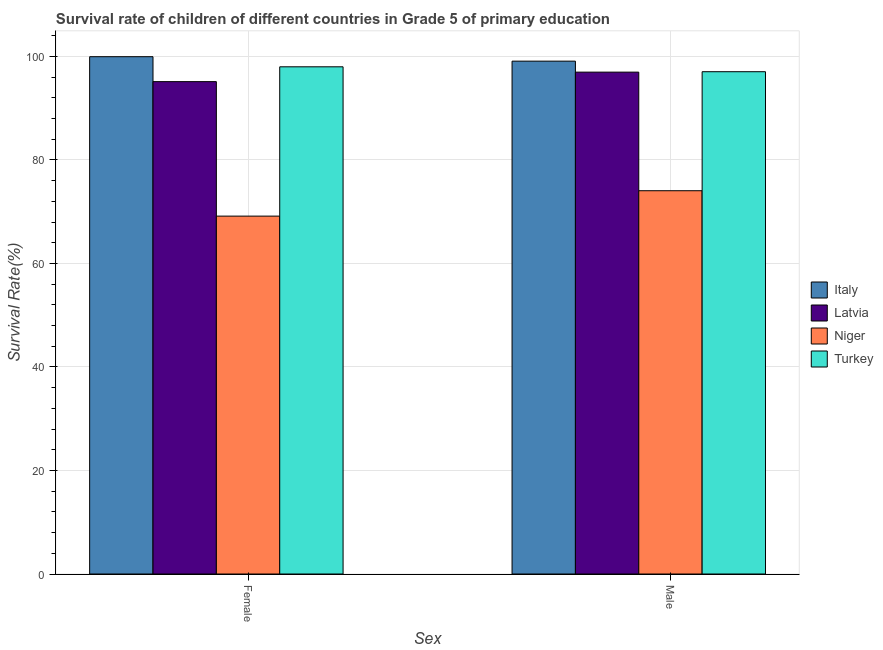Are the number of bars per tick equal to the number of legend labels?
Your answer should be very brief. Yes. Are the number of bars on each tick of the X-axis equal?
Give a very brief answer. Yes. How many bars are there on the 2nd tick from the right?
Keep it short and to the point. 4. What is the survival rate of female students in primary education in Italy?
Keep it short and to the point. 99.95. Across all countries, what is the maximum survival rate of male students in primary education?
Provide a succinct answer. 99.08. Across all countries, what is the minimum survival rate of female students in primary education?
Give a very brief answer. 69.14. In which country was the survival rate of male students in primary education minimum?
Your answer should be very brief. Niger. What is the total survival rate of female students in primary education in the graph?
Your answer should be compact. 362.21. What is the difference between the survival rate of male students in primary education in Niger and that in Turkey?
Offer a terse response. -23. What is the difference between the survival rate of female students in primary education in Latvia and the survival rate of male students in primary education in Italy?
Your answer should be compact. -3.96. What is the average survival rate of male students in primary education per country?
Offer a terse response. 91.78. What is the difference between the survival rate of male students in primary education and survival rate of female students in primary education in Turkey?
Make the answer very short. -0.95. What is the ratio of the survival rate of female students in primary education in Turkey to that in Latvia?
Give a very brief answer. 1.03. What does the 3rd bar from the left in Male represents?
Offer a very short reply. Niger. What does the 2nd bar from the right in Female represents?
Make the answer very short. Niger. How many bars are there?
Ensure brevity in your answer.  8. Are all the bars in the graph horizontal?
Offer a terse response. No. How many countries are there in the graph?
Offer a very short reply. 4. What is the difference between two consecutive major ticks on the Y-axis?
Provide a short and direct response. 20. Does the graph contain grids?
Ensure brevity in your answer.  Yes. How many legend labels are there?
Provide a succinct answer. 4. What is the title of the graph?
Provide a succinct answer. Survival rate of children of different countries in Grade 5 of primary education. What is the label or title of the X-axis?
Your answer should be compact. Sex. What is the label or title of the Y-axis?
Your response must be concise. Survival Rate(%). What is the Survival Rate(%) of Italy in Female?
Your response must be concise. 99.95. What is the Survival Rate(%) in Latvia in Female?
Keep it short and to the point. 95.13. What is the Survival Rate(%) of Niger in Female?
Offer a very short reply. 69.14. What is the Survival Rate(%) of Turkey in Female?
Give a very brief answer. 97.99. What is the Survival Rate(%) of Italy in Male?
Ensure brevity in your answer.  99.08. What is the Survival Rate(%) of Latvia in Male?
Your answer should be compact. 96.96. What is the Survival Rate(%) in Niger in Male?
Provide a short and direct response. 74.05. What is the Survival Rate(%) of Turkey in Male?
Offer a very short reply. 97.04. Across all Sex, what is the maximum Survival Rate(%) in Italy?
Make the answer very short. 99.95. Across all Sex, what is the maximum Survival Rate(%) in Latvia?
Your answer should be compact. 96.96. Across all Sex, what is the maximum Survival Rate(%) of Niger?
Your answer should be compact. 74.05. Across all Sex, what is the maximum Survival Rate(%) in Turkey?
Provide a short and direct response. 97.99. Across all Sex, what is the minimum Survival Rate(%) in Italy?
Ensure brevity in your answer.  99.08. Across all Sex, what is the minimum Survival Rate(%) of Latvia?
Offer a very short reply. 95.13. Across all Sex, what is the minimum Survival Rate(%) in Niger?
Make the answer very short. 69.14. Across all Sex, what is the minimum Survival Rate(%) in Turkey?
Offer a very short reply. 97.04. What is the total Survival Rate(%) in Italy in the graph?
Provide a succinct answer. 199.03. What is the total Survival Rate(%) in Latvia in the graph?
Make the answer very short. 192.09. What is the total Survival Rate(%) in Niger in the graph?
Make the answer very short. 143.19. What is the total Survival Rate(%) of Turkey in the graph?
Keep it short and to the point. 195.03. What is the difference between the Survival Rate(%) of Italy in Female and that in Male?
Your answer should be compact. 0.86. What is the difference between the Survival Rate(%) in Latvia in Female and that in Male?
Ensure brevity in your answer.  -1.83. What is the difference between the Survival Rate(%) of Niger in Female and that in Male?
Provide a succinct answer. -4.91. What is the difference between the Survival Rate(%) in Turkey in Female and that in Male?
Provide a succinct answer. 0.95. What is the difference between the Survival Rate(%) in Italy in Female and the Survival Rate(%) in Latvia in Male?
Offer a very short reply. 2.98. What is the difference between the Survival Rate(%) of Italy in Female and the Survival Rate(%) of Niger in Male?
Offer a very short reply. 25.9. What is the difference between the Survival Rate(%) in Italy in Female and the Survival Rate(%) in Turkey in Male?
Offer a very short reply. 2.9. What is the difference between the Survival Rate(%) in Latvia in Female and the Survival Rate(%) in Niger in Male?
Your answer should be compact. 21.08. What is the difference between the Survival Rate(%) in Latvia in Female and the Survival Rate(%) in Turkey in Male?
Ensure brevity in your answer.  -1.92. What is the difference between the Survival Rate(%) in Niger in Female and the Survival Rate(%) in Turkey in Male?
Make the answer very short. -27.9. What is the average Survival Rate(%) in Italy per Sex?
Your answer should be very brief. 99.51. What is the average Survival Rate(%) of Latvia per Sex?
Make the answer very short. 96.04. What is the average Survival Rate(%) in Niger per Sex?
Give a very brief answer. 71.6. What is the average Survival Rate(%) of Turkey per Sex?
Your answer should be compact. 97.52. What is the difference between the Survival Rate(%) in Italy and Survival Rate(%) in Latvia in Female?
Offer a terse response. 4.82. What is the difference between the Survival Rate(%) in Italy and Survival Rate(%) in Niger in Female?
Offer a terse response. 30.8. What is the difference between the Survival Rate(%) in Italy and Survival Rate(%) in Turkey in Female?
Offer a terse response. 1.95. What is the difference between the Survival Rate(%) in Latvia and Survival Rate(%) in Niger in Female?
Offer a very short reply. 25.98. What is the difference between the Survival Rate(%) of Latvia and Survival Rate(%) of Turkey in Female?
Ensure brevity in your answer.  -2.86. What is the difference between the Survival Rate(%) in Niger and Survival Rate(%) in Turkey in Female?
Your answer should be very brief. -28.85. What is the difference between the Survival Rate(%) in Italy and Survival Rate(%) in Latvia in Male?
Provide a succinct answer. 2.12. What is the difference between the Survival Rate(%) of Italy and Survival Rate(%) of Niger in Male?
Provide a short and direct response. 25.03. What is the difference between the Survival Rate(%) in Italy and Survival Rate(%) in Turkey in Male?
Offer a very short reply. 2.04. What is the difference between the Survival Rate(%) in Latvia and Survival Rate(%) in Niger in Male?
Your response must be concise. 22.91. What is the difference between the Survival Rate(%) in Latvia and Survival Rate(%) in Turkey in Male?
Keep it short and to the point. -0.08. What is the difference between the Survival Rate(%) of Niger and Survival Rate(%) of Turkey in Male?
Keep it short and to the point. -23. What is the ratio of the Survival Rate(%) in Italy in Female to that in Male?
Make the answer very short. 1.01. What is the ratio of the Survival Rate(%) of Latvia in Female to that in Male?
Your response must be concise. 0.98. What is the ratio of the Survival Rate(%) of Niger in Female to that in Male?
Keep it short and to the point. 0.93. What is the ratio of the Survival Rate(%) in Turkey in Female to that in Male?
Provide a succinct answer. 1.01. What is the difference between the highest and the second highest Survival Rate(%) of Italy?
Keep it short and to the point. 0.86. What is the difference between the highest and the second highest Survival Rate(%) in Latvia?
Make the answer very short. 1.83. What is the difference between the highest and the second highest Survival Rate(%) in Niger?
Provide a succinct answer. 4.91. What is the difference between the highest and the second highest Survival Rate(%) in Turkey?
Your answer should be compact. 0.95. What is the difference between the highest and the lowest Survival Rate(%) in Italy?
Offer a terse response. 0.86. What is the difference between the highest and the lowest Survival Rate(%) of Latvia?
Your answer should be very brief. 1.83. What is the difference between the highest and the lowest Survival Rate(%) of Niger?
Keep it short and to the point. 4.91. What is the difference between the highest and the lowest Survival Rate(%) in Turkey?
Your answer should be very brief. 0.95. 